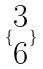Convert formula to latex. <formula><loc_0><loc_0><loc_500><loc_500>\{ \begin{matrix} 3 \\ 6 \end{matrix} \}</formula> 